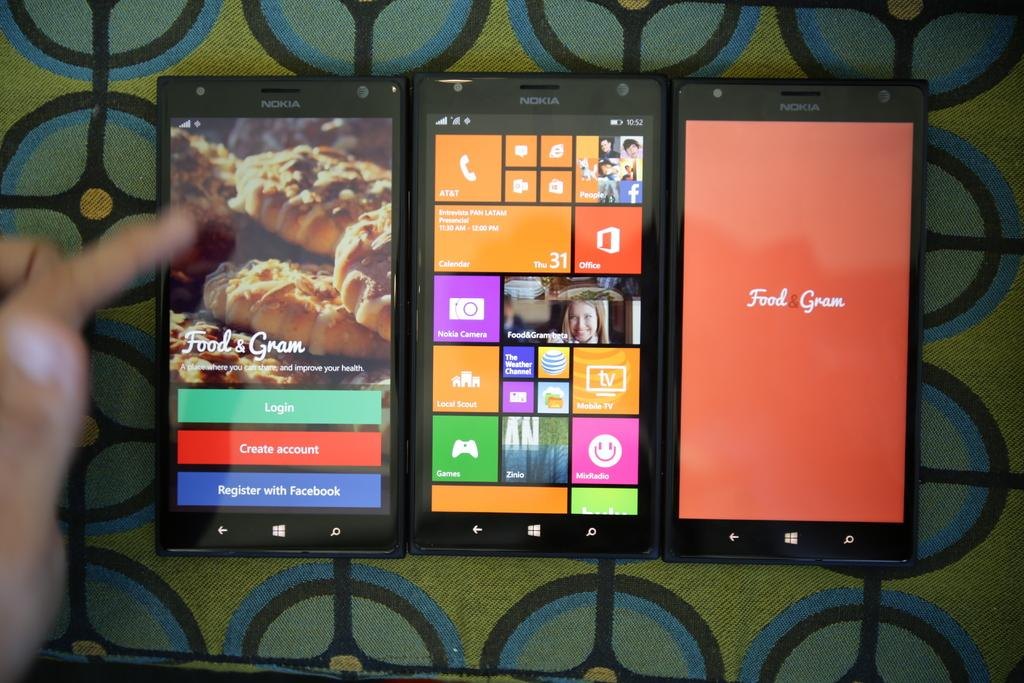<image>
Create a compact narrative representing the image presented. an orange sign that says food and gram on a phone 